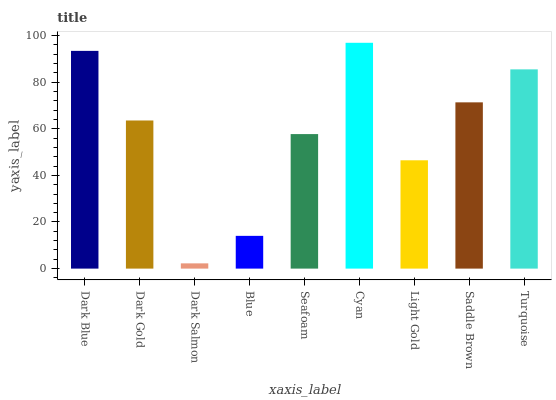Is Dark Salmon the minimum?
Answer yes or no. Yes. Is Cyan the maximum?
Answer yes or no. Yes. Is Dark Gold the minimum?
Answer yes or no. No. Is Dark Gold the maximum?
Answer yes or no. No. Is Dark Blue greater than Dark Gold?
Answer yes or no. Yes. Is Dark Gold less than Dark Blue?
Answer yes or no. Yes. Is Dark Gold greater than Dark Blue?
Answer yes or no. No. Is Dark Blue less than Dark Gold?
Answer yes or no. No. Is Dark Gold the high median?
Answer yes or no. Yes. Is Dark Gold the low median?
Answer yes or no. Yes. Is Seafoam the high median?
Answer yes or no. No. Is Turquoise the low median?
Answer yes or no. No. 